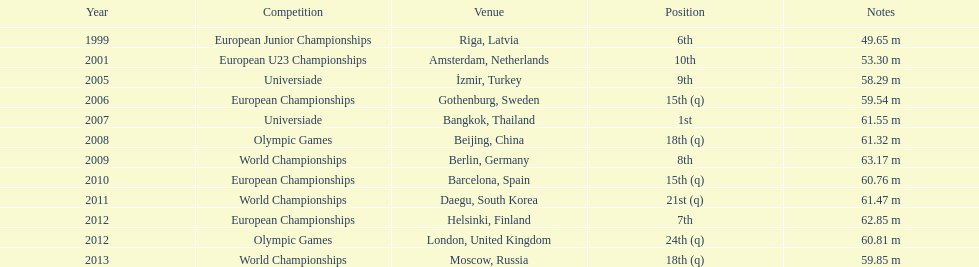Can you give me this table as a dict? {'header': ['Year', 'Competition', 'Venue', 'Position', 'Notes'], 'rows': [['1999', 'European Junior Championships', 'Riga, Latvia', '6th', '49.65 m'], ['2001', 'European U23 Championships', 'Amsterdam, Netherlands', '10th', '53.30 m'], ['2005', 'Universiade', 'İzmir, Turkey', '9th', '58.29 m'], ['2006', 'European Championships', 'Gothenburg, Sweden', '15th (q)', '59.54 m'], ['2007', 'Universiade', 'Bangkok, Thailand', '1st', '61.55 m'], ['2008', 'Olympic Games', 'Beijing, China', '18th (q)', '61.32 m'], ['2009', 'World Championships', 'Berlin, Germany', '8th', '63.17 m'], ['2010', 'European Championships', 'Barcelona, Spain', '15th (q)', '60.76 m'], ['2011', 'World Championships', 'Daegu, South Korea', '21st (q)', '61.47 m'], ['2012', 'European Championships', 'Helsinki, Finland', '7th', '62.85 m'], ['2012', 'Olympic Games', 'London, United Kingdom', '24th (q)', '60.81 m'], ['2013', 'World Championships', 'Moscow, Russia', '18th (q)', '59.85 m']]} Which year saw a recorded distance of merely 5 2001. 